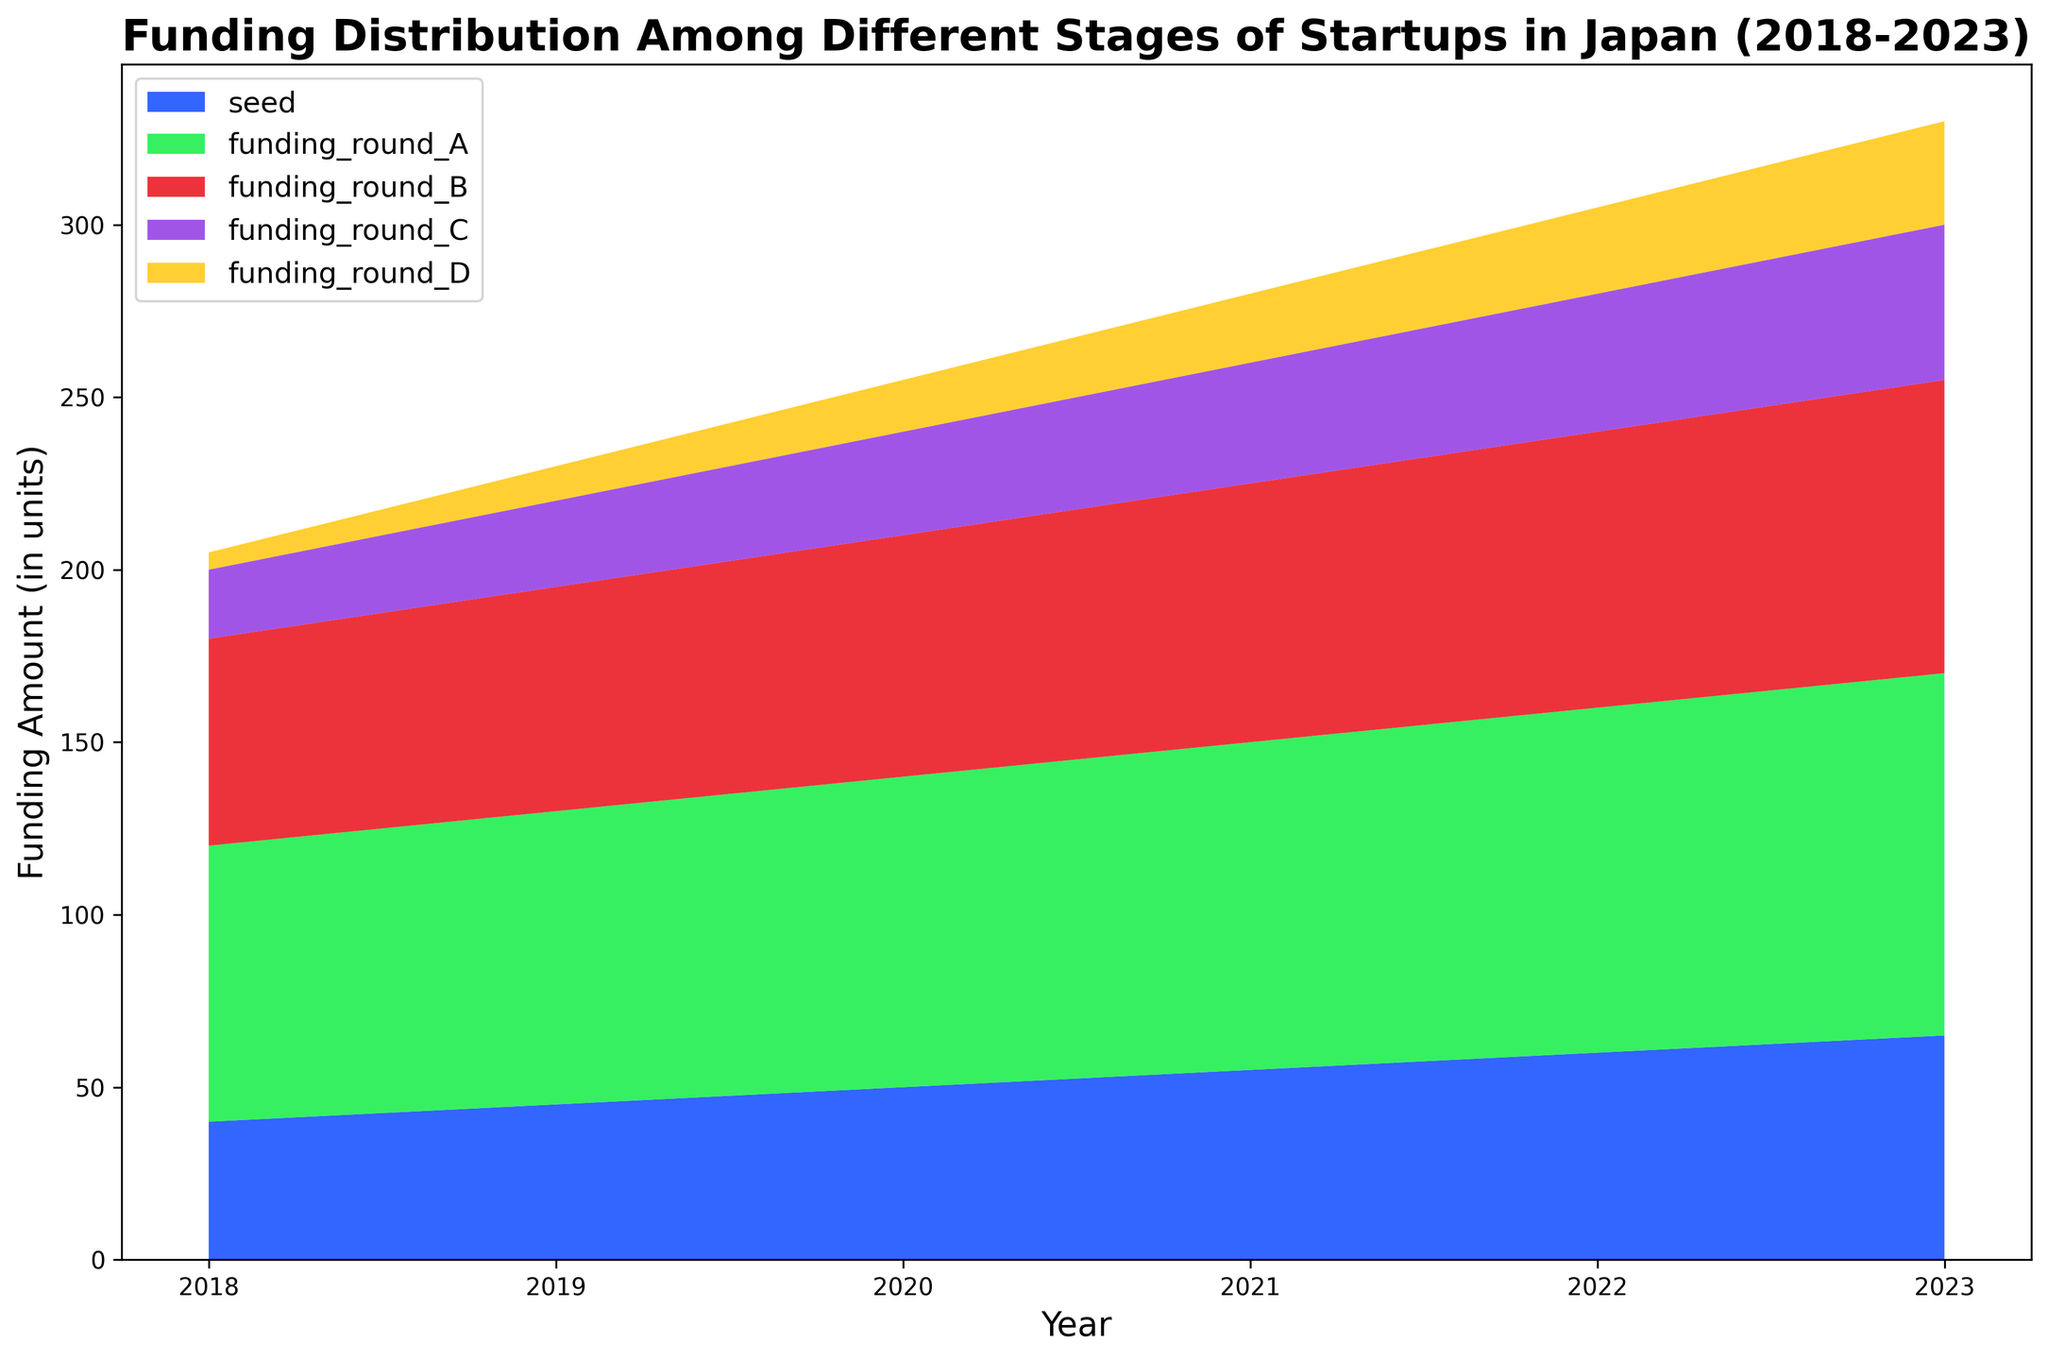What's the overall trend in seed funding from 2018 to 2023? Observing the area chart, the band representing seed funding is increasing in height over the years, indicating a rise in seed funding. For example, it starts lower in 2018 and grows gradually each year until 2023.
Answer: Increasing trend Which funding stage consistently has the highest amount throughout the years? By examining the topmost band in the area chart, which represents funding_round_A, it is noticeable that funding_round_A consistently has the highest amount each year as it remains at the top across all years from 2018 to 2023.
Answer: Funding Round A What's the difference in total funding amount between 2022 and 2023? To find the total funding amount for each year, sum the values for each stage in that year. For 2022: 60 + 100 + 80 + 40 + 25 = 305. For 2023: 65 + 105 + 85 + 45 + 30 = 330. The difference is 330 - 305 = 25.
Answer: 25 units Which stage shows the largest growth in funding from 2018 to 2023? Calculating the differences for each stage from 2018 to 2023. Seed: 65 - 40 = 25, Round A: 105 - 80 = 25, Round B: 85 - 60 = 25, Round C: 45 - 20 = 25, Round D: 30 - 5 = 25. Since all increments are equal, all stages show the same growth.
Answer: All stages grow equally How does the funding distribution in 2021 compare to 2023? Observing and comparing the relative sizes of each stage's bands from 2021 to 2023, we see similar trends with increased heights in 2023, suggesting overall increased funding amounts while maintaining proportional distribution among the stages.
Answer: Similar distribution, increased funding If you add the funding amounts for seed and funding round D in 2020, what do you get? Looking at the chart, in 2020, seed funding is 50 and funding round D is 15. Adding these together gives 50 + 15 = 65.
Answer: 65 units In which year did funding for funding_round_C first reach 35 units? Observing the progression of funding_round_C in the chart, funding_round_C first hits 35 units in 2021.
Answer: 2021 What is the total number of funding stages depicted in the chart? Counting the different bands or stages shown in the area chart depicts five distinct stages: seed, funding_round_A, funding_round_B, funding_round_C, and funding_round_D.
Answer: 5 stages 